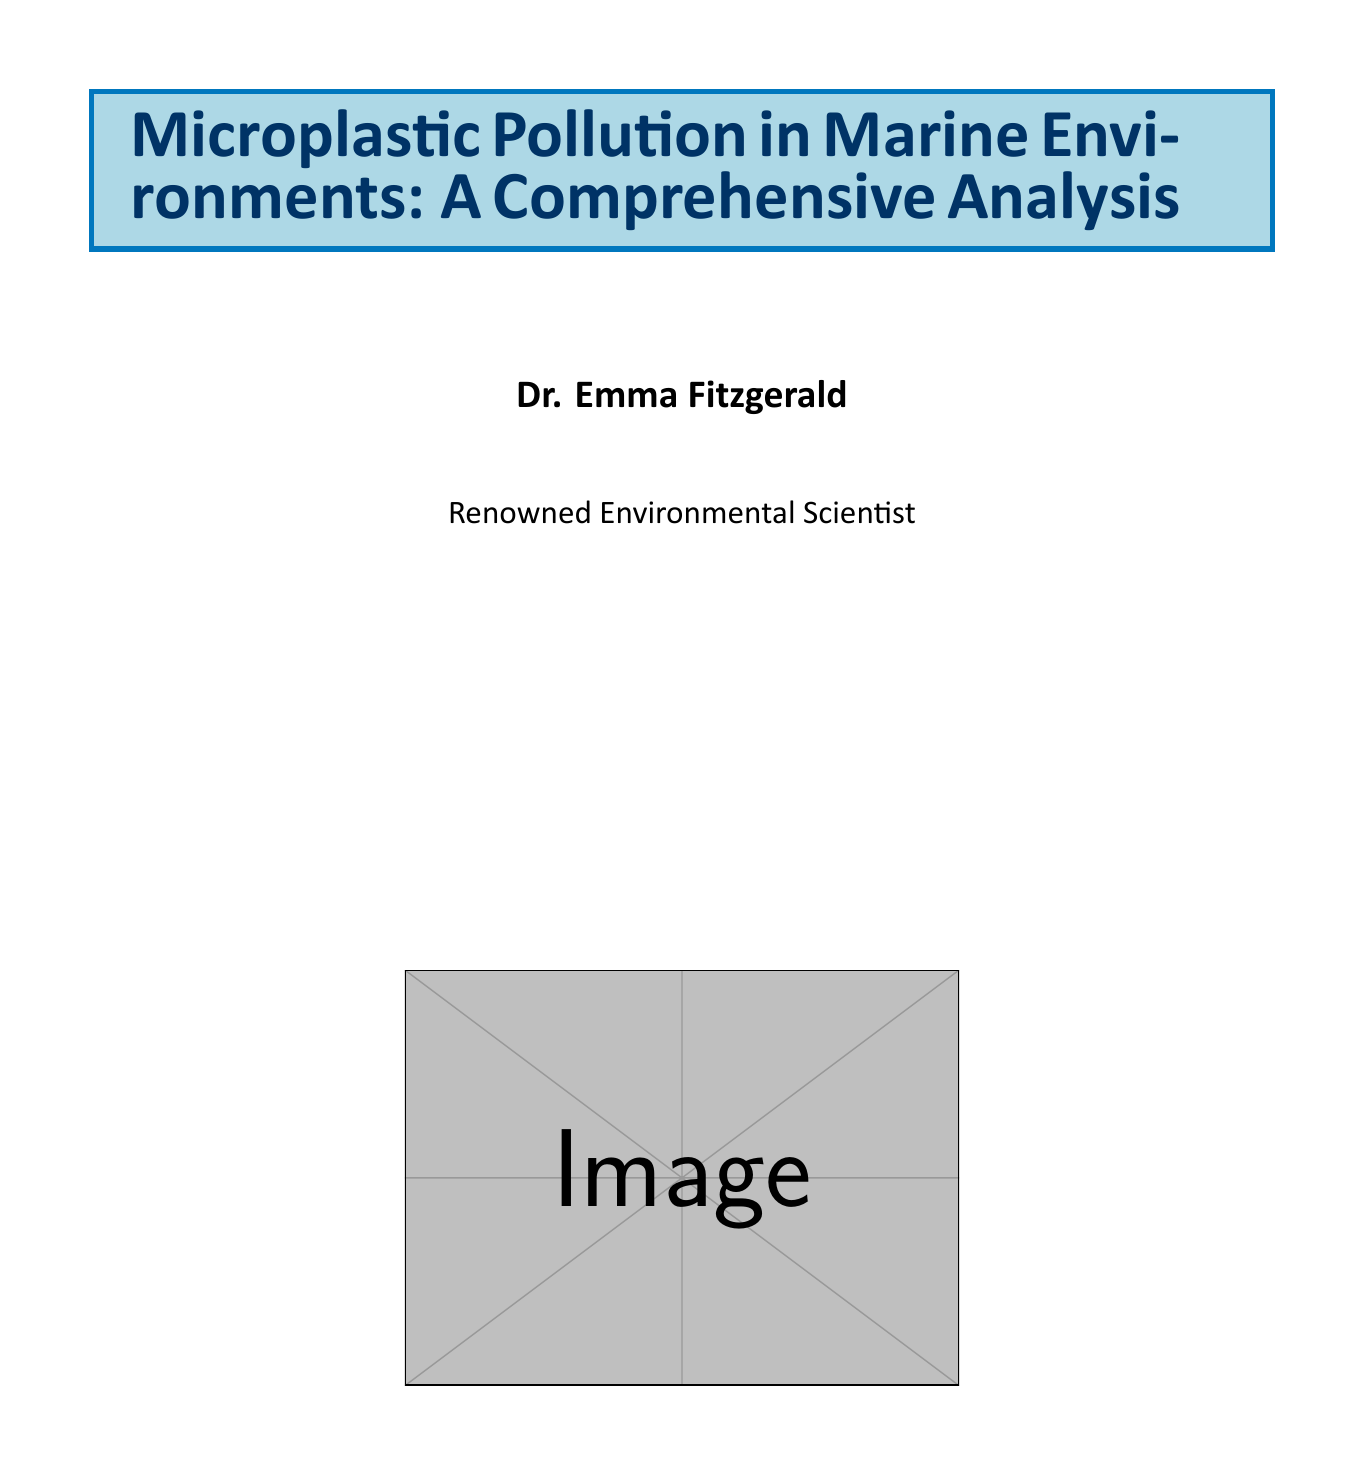What is the estimated amount of plastic entering the oceans annually? The document states that 8 million tons of plastic enter the oceans each year.
Answer: 8 million tons How many marine species are known to have encountered plastic debris? The report mentions that 700 species have encountered plastic debris in the oceans.
Answer: 700 species What are the two types of microplastics mentioned? The document identifies primary and secondary microplastics as the two types discussed.
Answer: Primary and secondary microplastics What is a significant industrial source of microplastic pollution? The report highlights plastic production facilities as a notable source of microplastic pollution.
Answer: Plastic production facilities Which ocean has large accumulations of microplastics observed? The study mentions the Great Pacific Garbage Patch as a location of significant microplastic accumulation.
Answer: Great Pacific Garbage Patch What approach is necessary to preserve marine ecosystems according to the conclusion? The conclusion emphasizes that a multi-faceted approach involving various stakeholders is necessary for preserving marine ecosystems.
Answer: Multi-faceted approach What is one potential solution to microplastic pollution mentioned? The report discusses the implementation of bans on single-use plastics as a potential solution.
Answer: Bans on single-use plastics Which campaign aims to improve consumer awareness about plastic consumption? The document refers to the UNEP's Clean Seas campaign as an initiative for consumer education on plastic reduction.
Answer: UNEP's Clean Seas campaign 